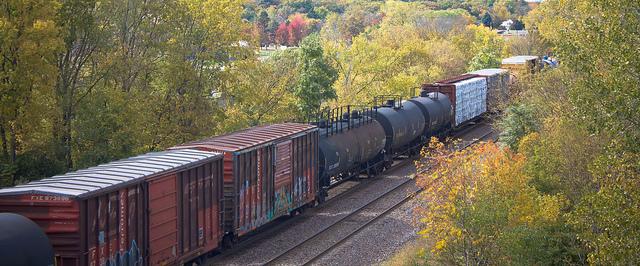How many train tracks do you see?
Answer briefly. 2. Is this a passenger train?
Quick response, please. No. Do all the trees have green leaves?
Keep it brief. No. Is this a real train?
Answer briefly. Yes. 